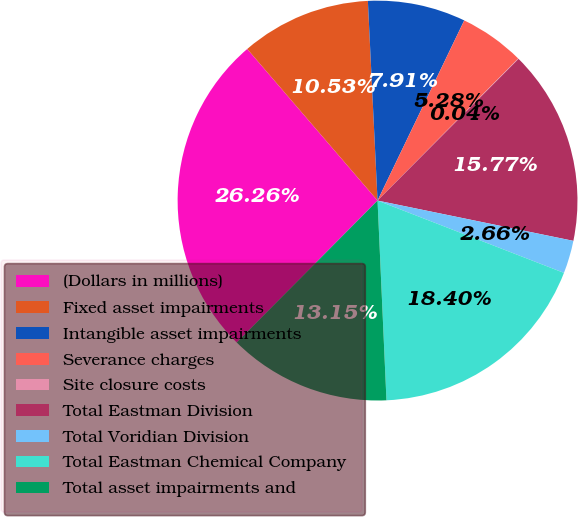Convert chart to OTSL. <chart><loc_0><loc_0><loc_500><loc_500><pie_chart><fcel>(Dollars in millions)<fcel>Fixed asset impairments<fcel>Intangible asset impairments<fcel>Severance charges<fcel>Site closure costs<fcel>Total Eastman Division<fcel>Total Voridian Division<fcel>Total Eastman Chemical Company<fcel>Total asset impairments and<nl><fcel>26.26%<fcel>10.53%<fcel>7.91%<fcel>5.28%<fcel>0.04%<fcel>15.77%<fcel>2.66%<fcel>18.4%<fcel>13.15%<nl></chart> 